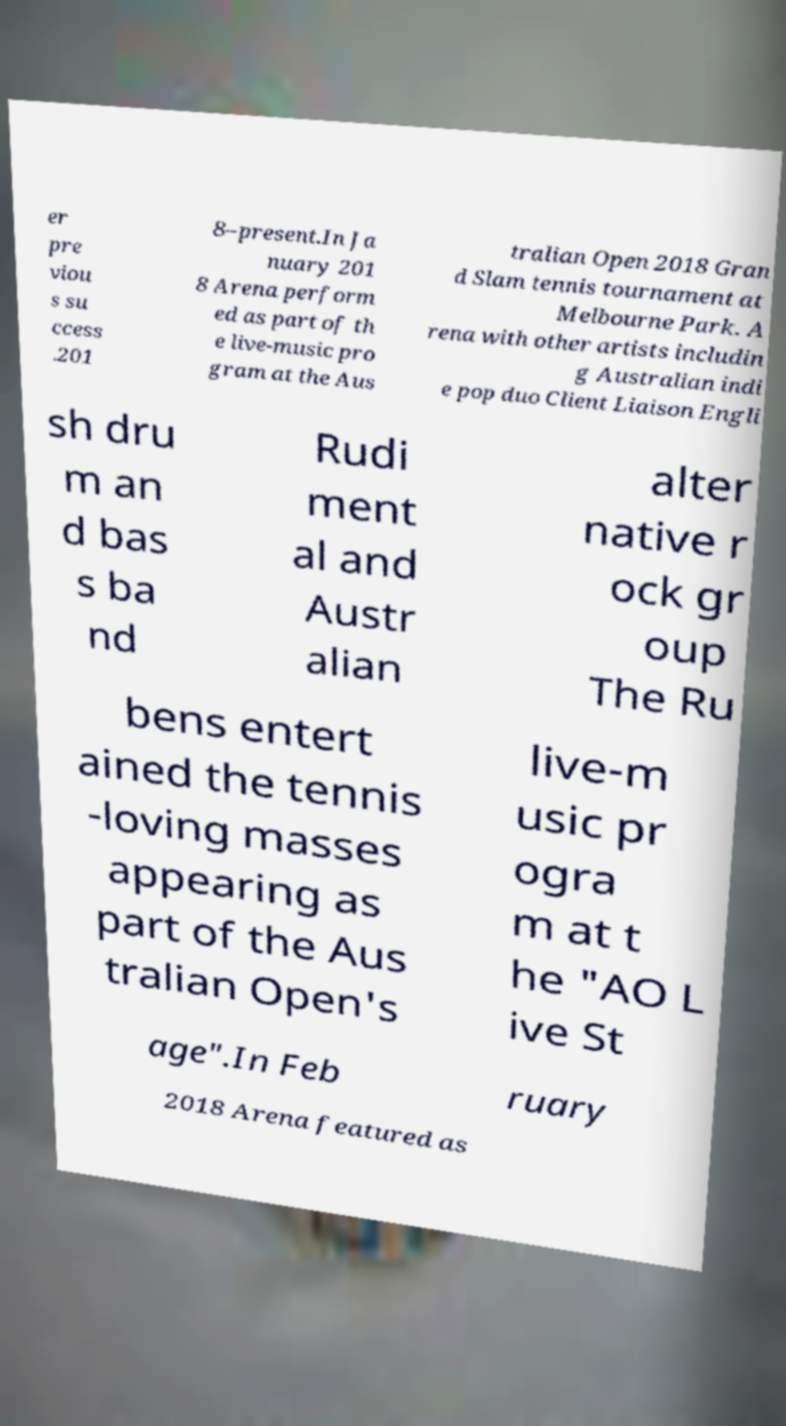Please read and relay the text visible in this image. What does it say? er pre viou s su ccess .201 8–present.In Ja nuary 201 8 Arena perform ed as part of th e live-music pro gram at the Aus tralian Open 2018 Gran d Slam tennis tournament at Melbourne Park. A rena with other artists includin g Australian indi e pop duo Client Liaison Engli sh dru m an d bas s ba nd Rudi ment al and Austr alian alter native r ock gr oup The Ru bens entert ained the tennis -loving masses appearing as part of the Aus tralian Open's live-m usic pr ogra m at t he "AO L ive St age".In Feb ruary 2018 Arena featured as 